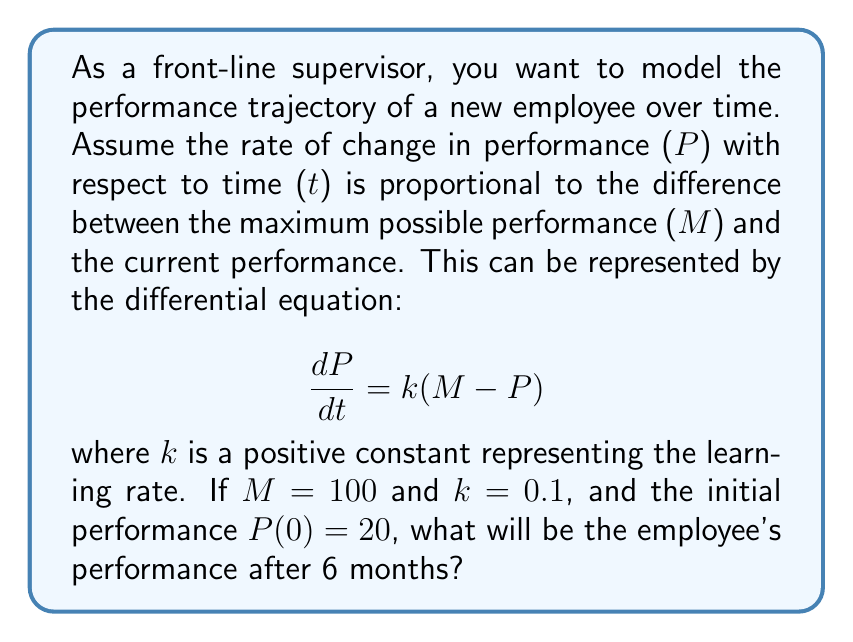Help me with this question. To solve this problem, we need to follow these steps:

1) The given differential equation is:
   $$\frac{dP}{dt} = k(M - P)$$

2) We are given that M = 100, k = 0.1, and P(0) = 20.

3) This is a first-order linear differential equation. The general solution is:
   $$P(t) = M + (P(0) - M)e^{-kt}$$

4) Substituting the given values:
   $$P(t) = 100 + (20 - 100)e^{-0.1t}$$
   $$P(t) = 100 - 80e^{-0.1t}$$

5) We want to find P(6), as 6 months have passed:
   $$P(6) = 100 - 80e^{-0.1(6)}$$
   $$P(6) = 100 - 80e^{-0.6}$$

6) Calculating this:
   $$P(6) = 100 - 80(0.5488)$$
   $$P(6) = 100 - 43.904$$
   $$P(6) = 56.096$$

7) Rounding to two decimal places:
   $$P(6) \approx 56.10$$
Answer: 56.10 